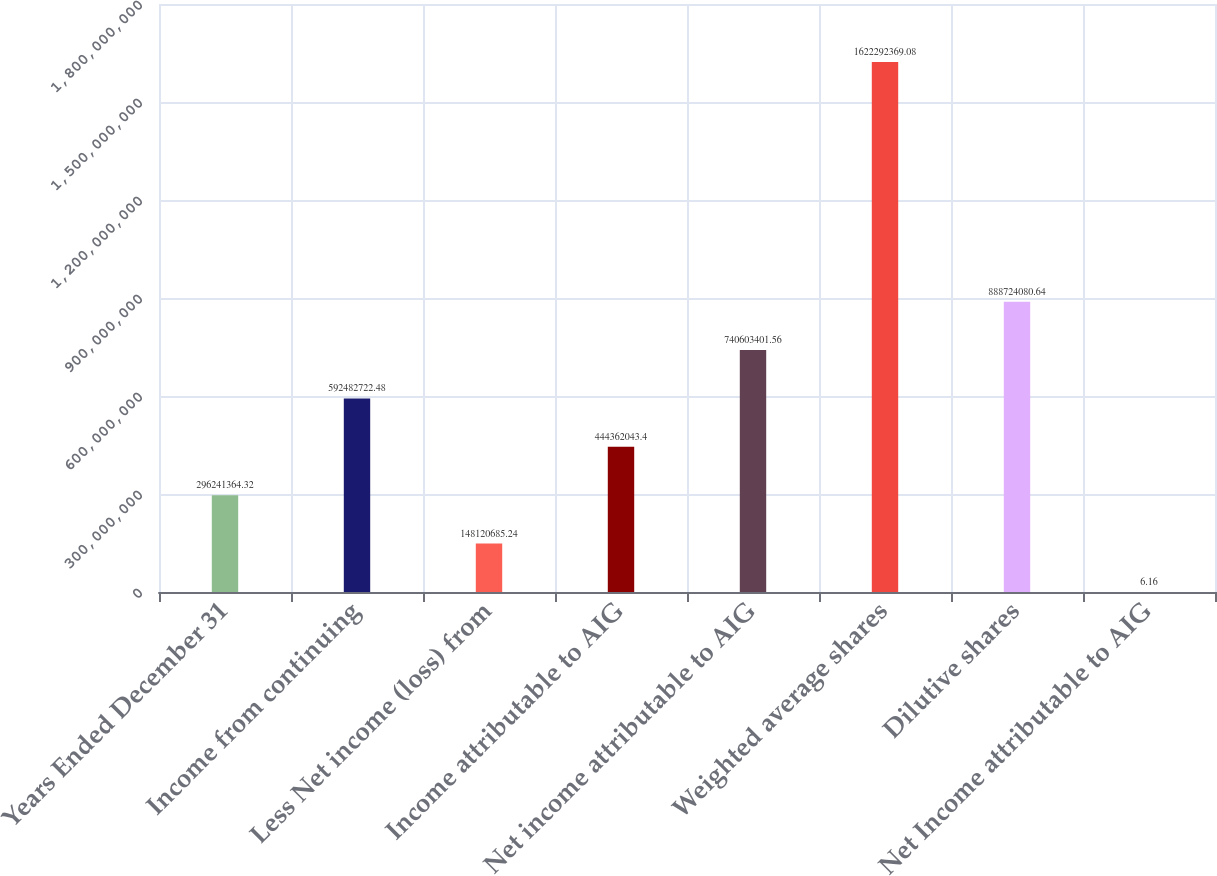Convert chart to OTSL. <chart><loc_0><loc_0><loc_500><loc_500><bar_chart><fcel>Years Ended December 31<fcel>Income from continuing<fcel>Less Net income (loss) from<fcel>Income attributable to AIG<fcel>Net income attributable to AIG<fcel>Weighted average shares<fcel>Dilutive shares<fcel>Net Income attributable to AIG<nl><fcel>2.96241e+08<fcel>5.92483e+08<fcel>1.48121e+08<fcel>4.44362e+08<fcel>7.40603e+08<fcel>1.62229e+09<fcel>8.88724e+08<fcel>6.16<nl></chart> 